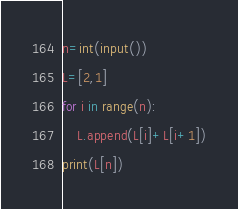Convert code to text. <code><loc_0><loc_0><loc_500><loc_500><_Python_>n=int(input())
L=[2,1]
for i in range(n):
    L.append(L[i]+L[i+1])
print(L[n])</code> 